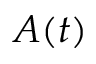<formula> <loc_0><loc_0><loc_500><loc_500>A ( t )</formula> 